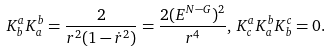Convert formula to latex. <formula><loc_0><loc_0><loc_500><loc_500>K ^ { a } _ { b } K ^ { b } _ { a } = \frac { 2 } { r ^ { 2 } ( 1 - \dot { r } ^ { 2 } ) } = \frac { 2 ( E ^ { N - G } ) ^ { 2 } } { r ^ { 4 } } , \, K ^ { a } _ { c } K ^ { b } _ { a } K ^ { c } _ { b } = 0 .</formula> 